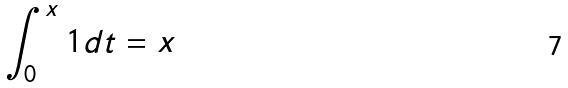Convert formula to latex. <formula><loc_0><loc_0><loc_500><loc_500>\int _ { 0 } ^ { x } 1 d t = x</formula> 